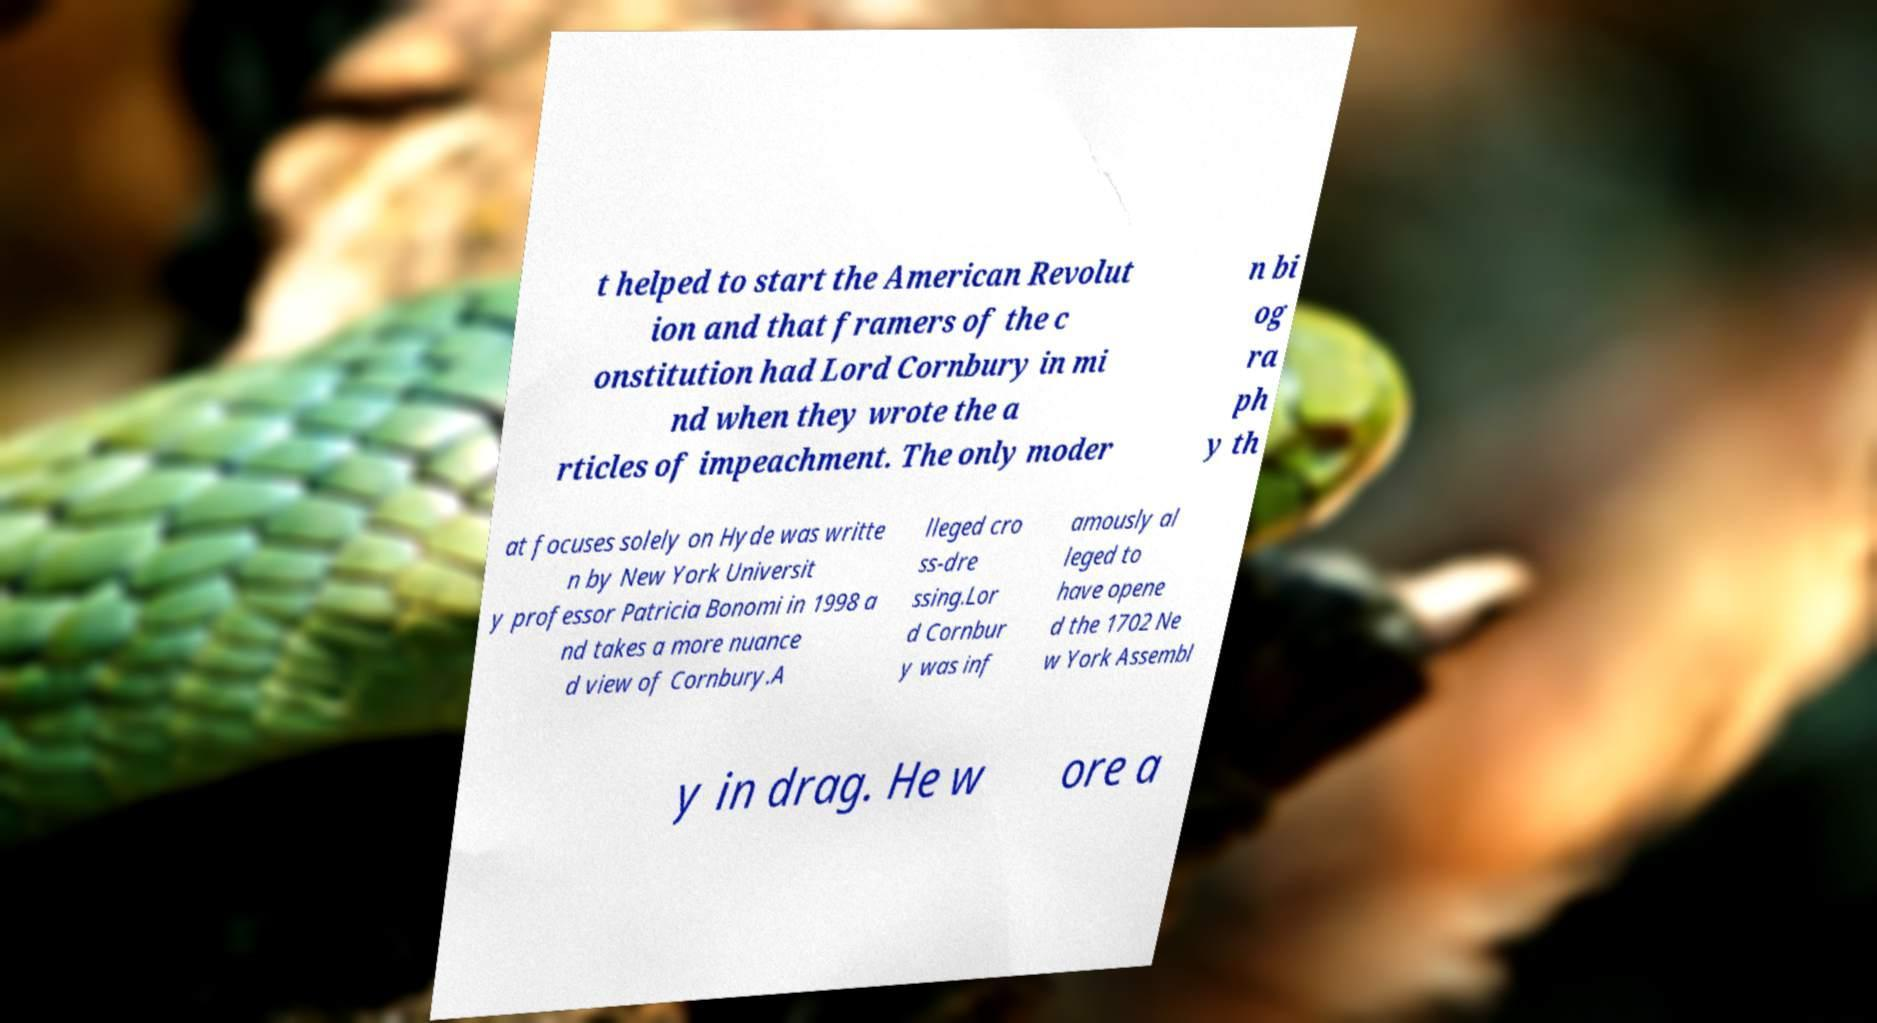There's text embedded in this image that I need extracted. Can you transcribe it verbatim? t helped to start the American Revolut ion and that framers of the c onstitution had Lord Cornbury in mi nd when they wrote the a rticles of impeachment. The only moder n bi og ra ph y th at focuses solely on Hyde was writte n by New York Universit y professor Patricia Bonomi in 1998 a nd takes a more nuance d view of Cornbury.A lleged cro ss-dre ssing.Lor d Cornbur y was inf amously al leged to have opene d the 1702 Ne w York Assembl y in drag. He w ore a 